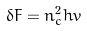<formula> <loc_0><loc_0><loc_500><loc_500>\delta F = n _ { c } ^ { 2 } h v</formula> 